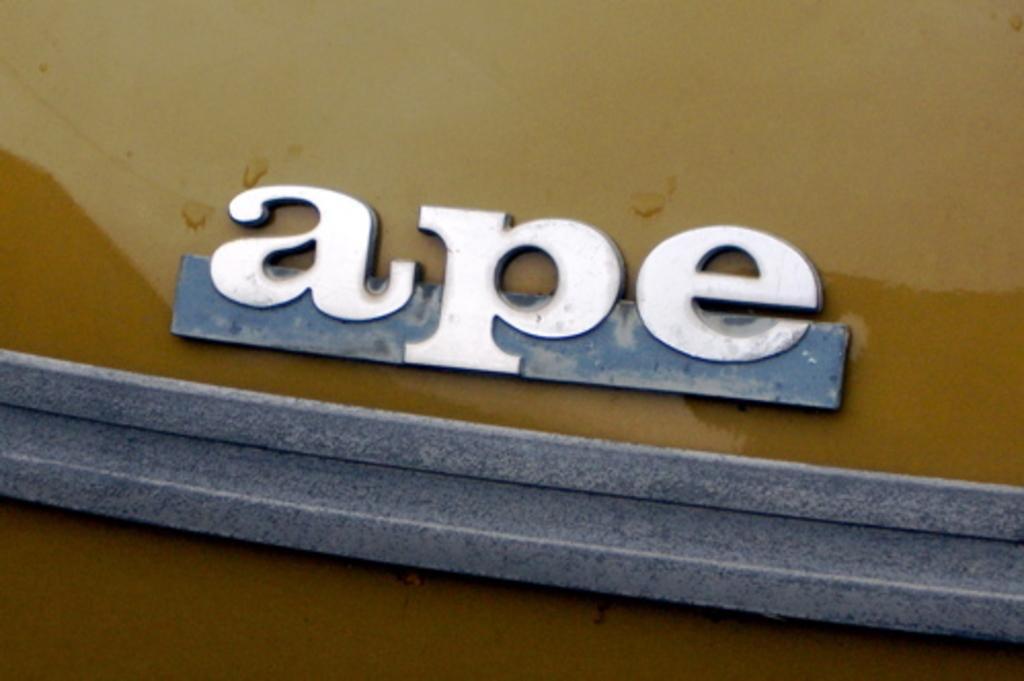Please provide a concise description of this image. In this picture I can see a name board attached to the vehicle. 